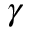<formula> <loc_0><loc_0><loc_500><loc_500>\gamma</formula> 